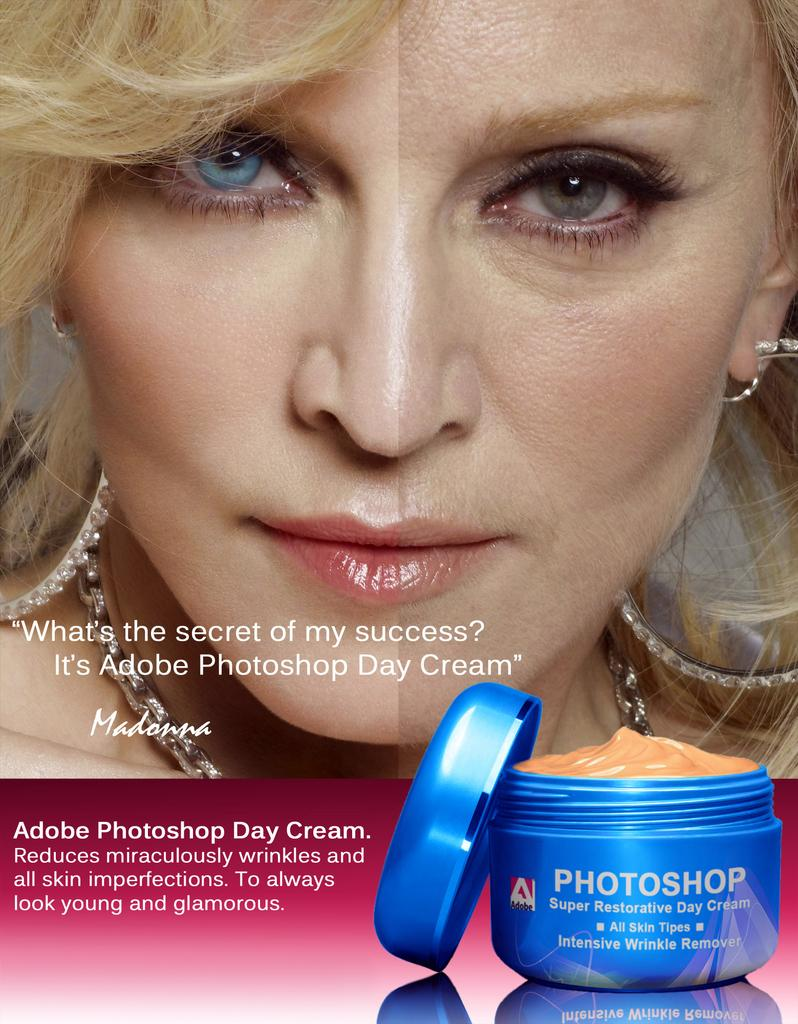<image>
Create a compact narrative representing the image presented. A split screen woman named Madonna advertising Adobe Photoshop. 